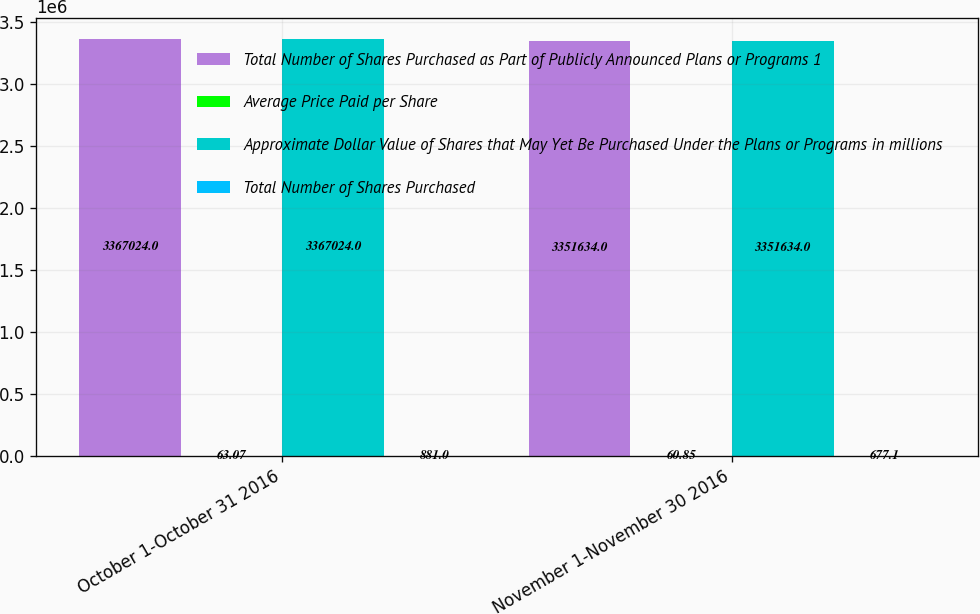<chart> <loc_0><loc_0><loc_500><loc_500><stacked_bar_chart><ecel><fcel>October 1-October 31 2016<fcel>November 1-November 30 2016<nl><fcel>Total Number of Shares Purchased as Part of Publicly Announced Plans or Programs 1<fcel>3.36702e+06<fcel>3.35163e+06<nl><fcel>Average Price Paid per Share<fcel>63.07<fcel>60.85<nl><fcel>Approximate Dollar Value of Shares that May Yet Be Purchased Under the Plans or Programs in millions<fcel>3.36702e+06<fcel>3.35163e+06<nl><fcel>Total Number of Shares Purchased<fcel>881<fcel>677.1<nl></chart> 